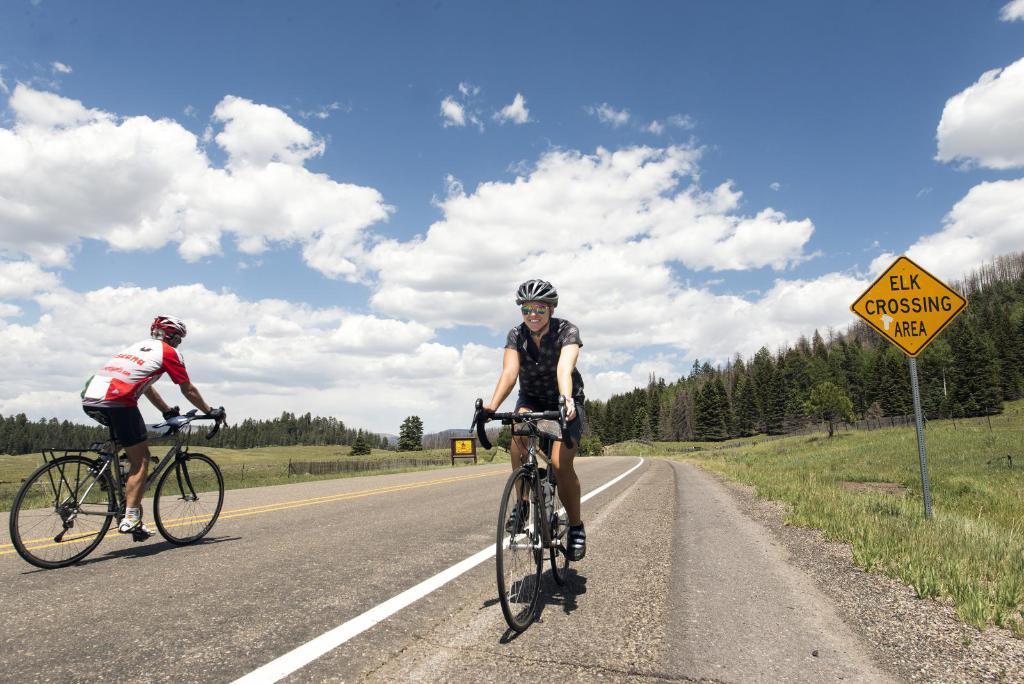Could you give a brief overview of what you see in this image? As we can see in the image there are two people wearing helmets and riding bicycles. There is grass, sign board, trees, sky and clouds. 